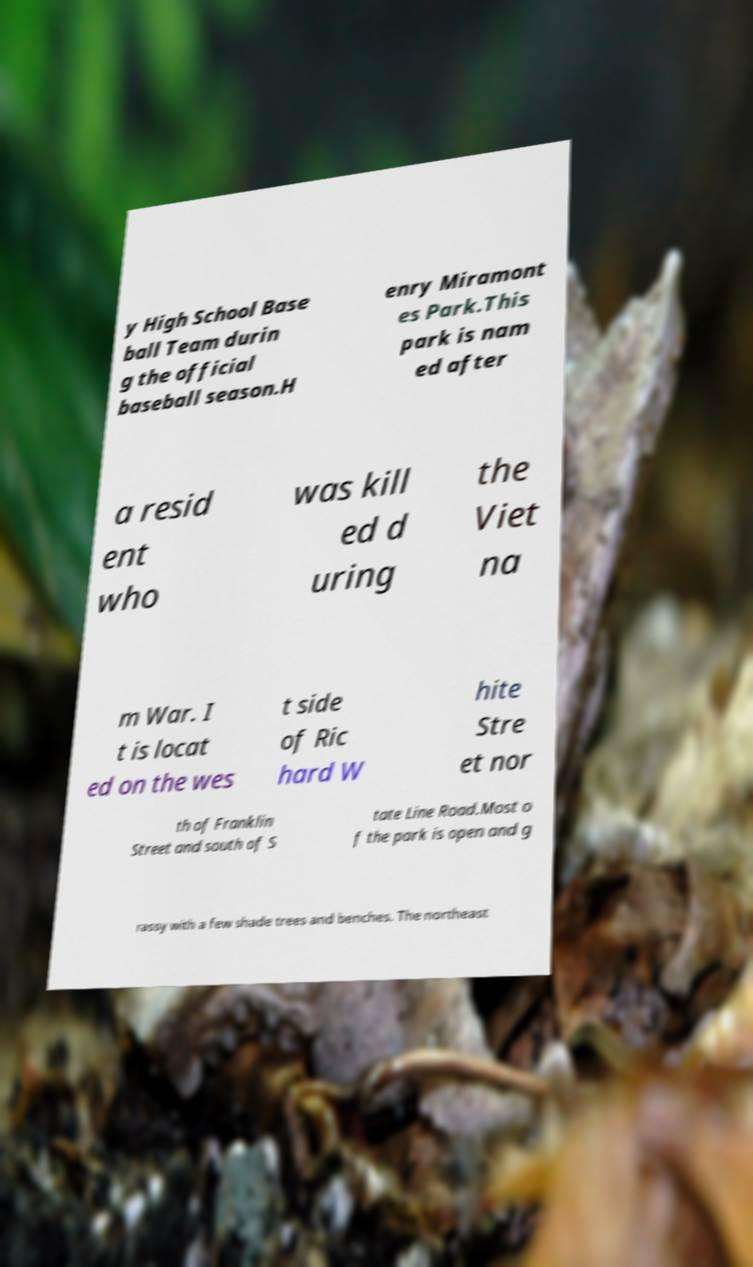Can you read and provide the text displayed in the image?This photo seems to have some interesting text. Can you extract and type it out for me? y High School Base ball Team durin g the official baseball season.H enry Miramont es Park.This park is nam ed after a resid ent who was kill ed d uring the Viet na m War. I t is locat ed on the wes t side of Ric hard W hite Stre et nor th of Franklin Street and south of S tate Line Road.Most o f the park is open and g rassy with a few shade trees and benches. The northeast 